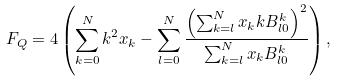Convert formula to latex. <formula><loc_0><loc_0><loc_500><loc_500>F _ { Q } = 4 \left ( \sum _ { k = 0 } ^ { N } k ^ { 2 } x _ { k } - \sum _ { l = 0 } ^ { N } \frac { \left ( \sum _ { k = l } ^ { N } x _ { k } k B ^ { k } _ { l 0 } \right ) ^ { 2 } } { \sum _ { k = l } ^ { N } x _ { k } B ^ { k } _ { l 0 } } \right ) ,</formula> 